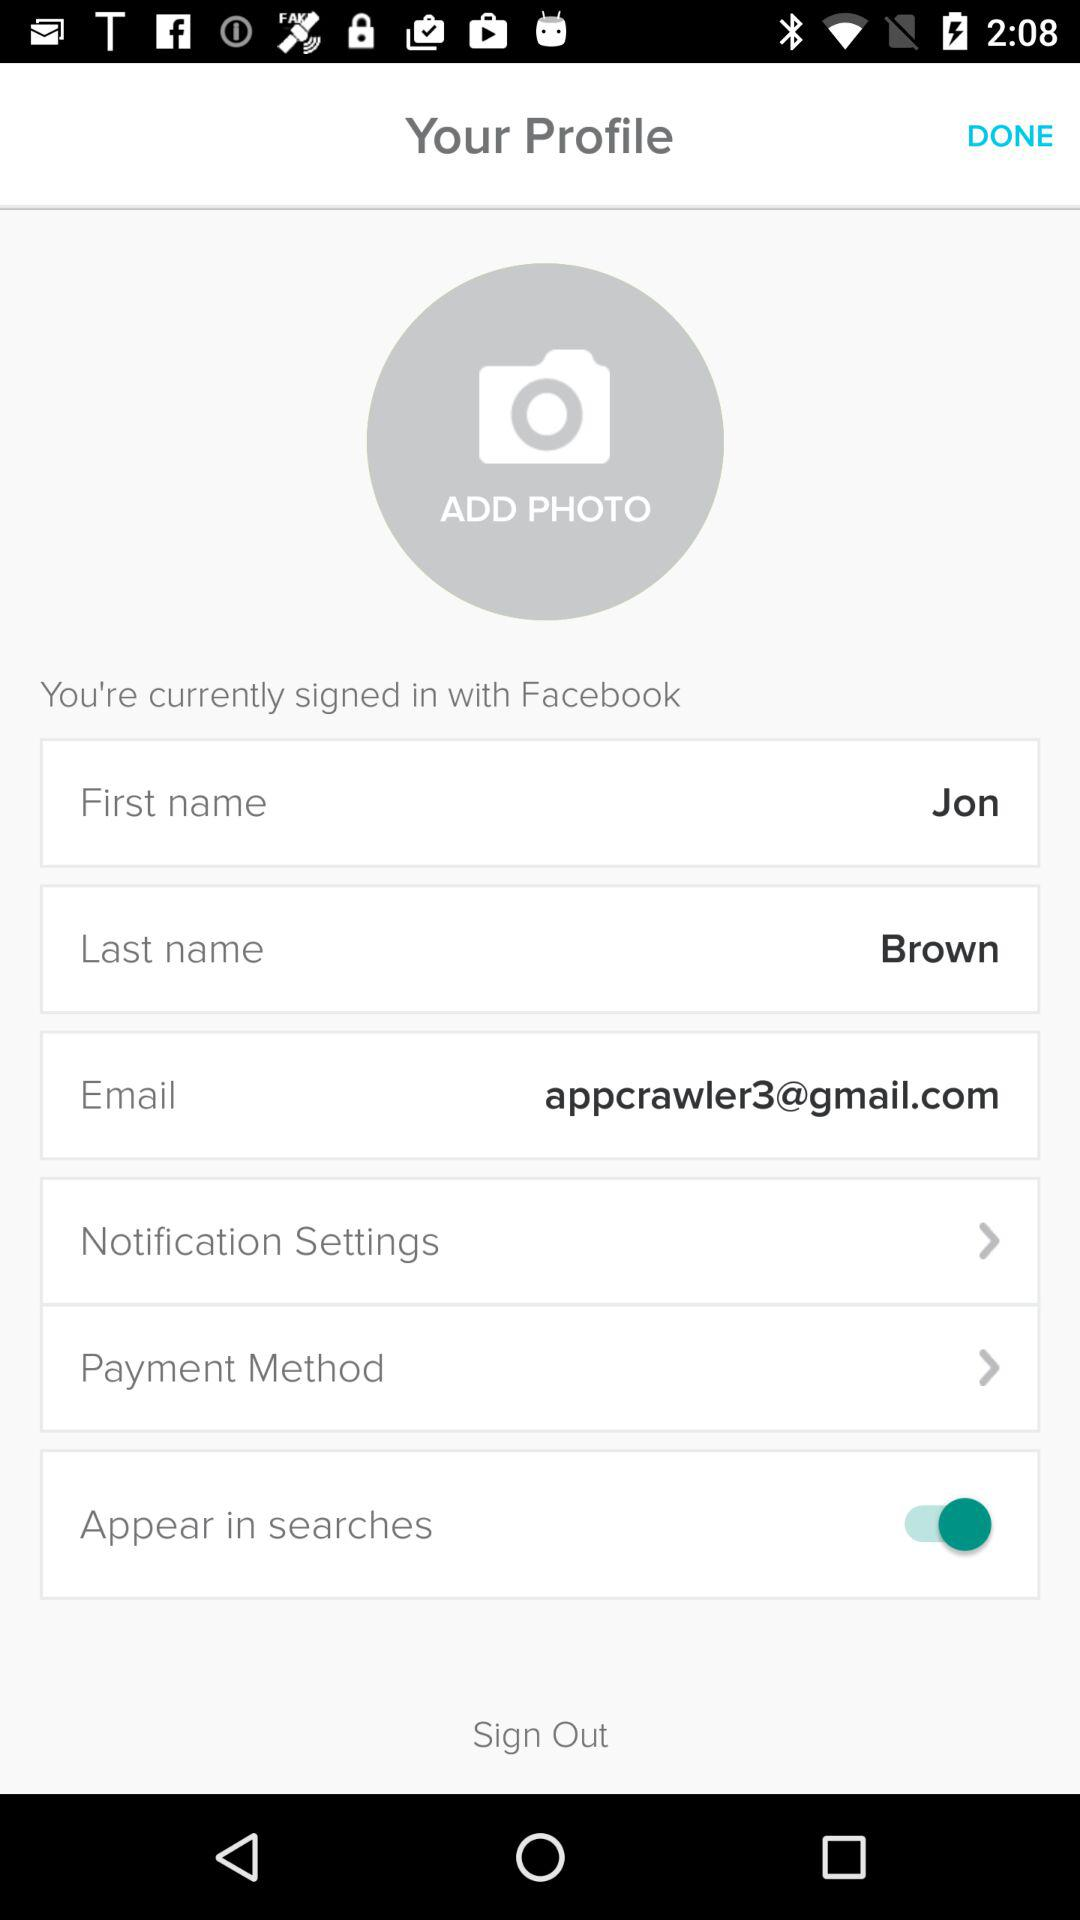What is the email address? The email address is appcrawler3@gmail.com. 